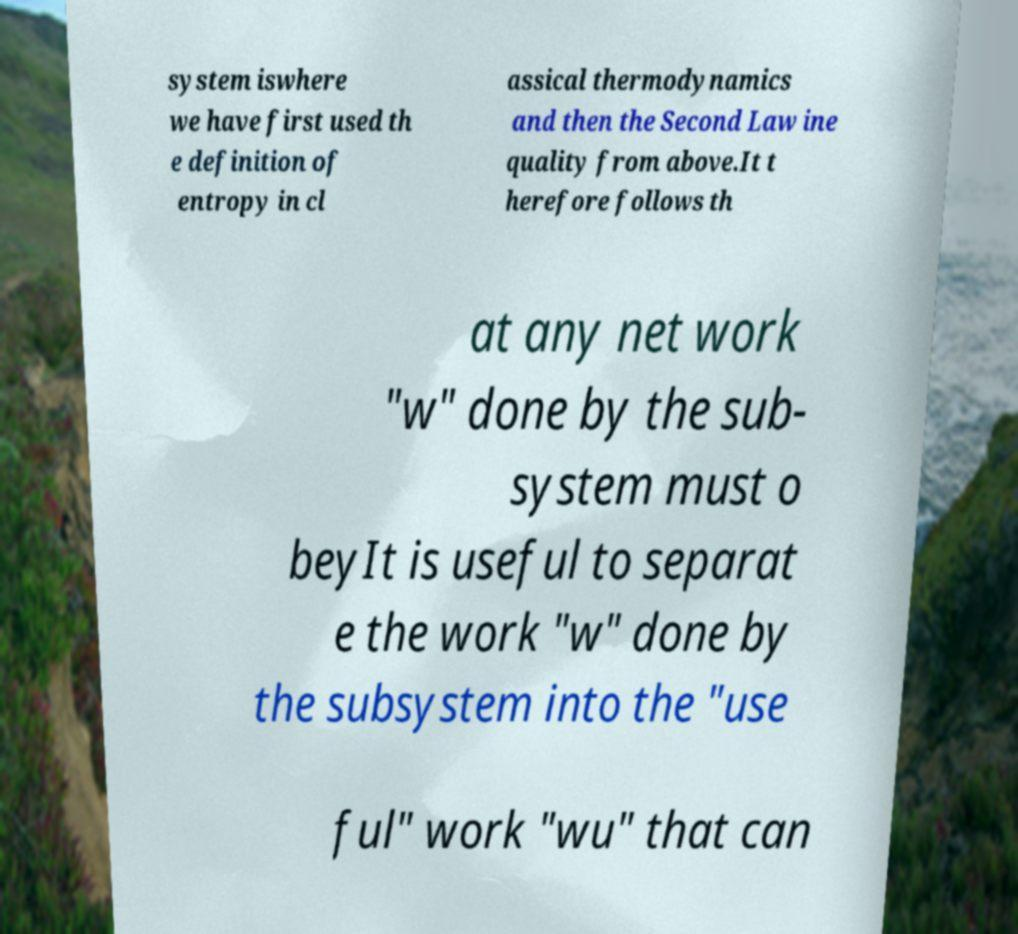Please identify and transcribe the text found in this image. system iswhere we have first used th e definition of entropy in cl assical thermodynamics and then the Second Law ine quality from above.It t herefore follows th at any net work "w" done by the sub- system must o beyIt is useful to separat e the work "w" done by the subsystem into the "use ful" work "wu" that can 